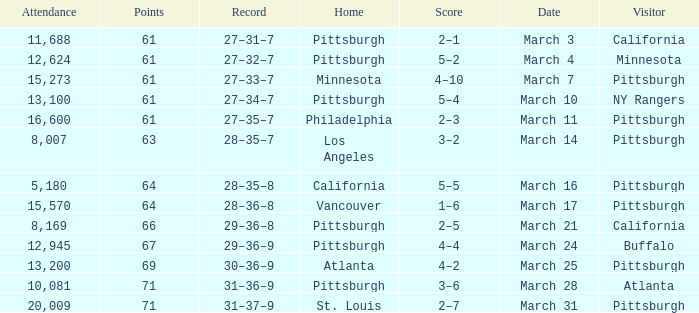I'm looking to parse the entire table for insights. Could you assist me with that? {'header': ['Attendance', 'Points', 'Record', 'Home', 'Score', 'Date', 'Visitor'], 'rows': [['11,688', '61', '27–31–7', 'Pittsburgh', '2–1', 'March 3', 'California'], ['12,624', '61', '27–32–7', 'Pittsburgh', '5–2', 'March 4', 'Minnesota'], ['15,273', '61', '27–33–7', 'Minnesota', '4–10', 'March 7', 'Pittsburgh'], ['13,100', '61', '27–34–7', 'Pittsburgh', '5–4', 'March 10', 'NY Rangers'], ['16,600', '61', '27–35–7', 'Philadelphia', '2–3', 'March 11', 'Pittsburgh'], ['8,007', '63', '28–35–7', 'Los Angeles', '3–2', 'March 14', 'Pittsburgh'], ['5,180', '64', '28–35–8', 'California', '5–5', 'March 16', 'Pittsburgh'], ['15,570', '64', '28–36–8', 'Vancouver', '1–6', 'March 17', 'Pittsburgh'], ['8,169', '66', '29–36–8', 'Pittsburgh', '2–5', 'March 21', 'California'], ['12,945', '67', '29–36–9', 'Pittsburgh', '4–4', 'March 24', 'Buffalo'], ['13,200', '69', '30–36–9', 'Atlanta', '4–2', 'March 25', 'Pittsburgh'], ['10,081', '71', '31–36–9', 'Pittsburgh', '3–6', 'March 28', 'Atlanta'], ['20,009', '71', '31–37–9', 'St. Louis', '2–7', 'March 31', 'Pittsburgh']]} What is the Score of the game with a Record of 31–37–9? 2–7. 